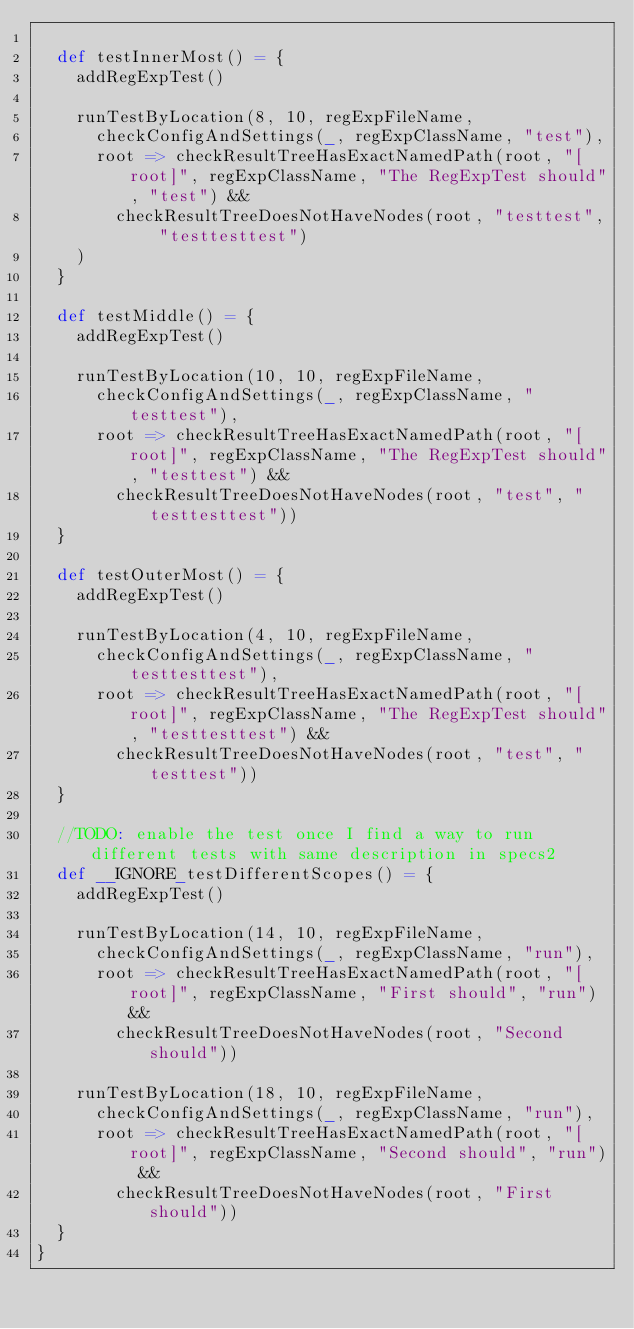Convert code to text. <code><loc_0><loc_0><loc_500><loc_500><_Scala_>
  def testInnerMost() = {
    addRegExpTest()

    runTestByLocation(8, 10, regExpFileName,
      checkConfigAndSettings(_, regExpClassName, "test"),
      root => checkResultTreeHasExactNamedPath(root, "[root]", regExpClassName, "The RegExpTest should", "test") &&
        checkResultTreeDoesNotHaveNodes(root, "testtest", "testtesttest")
    )
  }

  def testMiddle() = {
    addRegExpTest()

    runTestByLocation(10, 10, regExpFileName,
      checkConfigAndSettings(_, regExpClassName, "testtest"),
      root => checkResultTreeHasExactNamedPath(root, "[root]", regExpClassName, "The RegExpTest should", "testtest") &&
        checkResultTreeDoesNotHaveNodes(root, "test", "testtesttest"))
  }

  def testOuterMost() = {
    addRegExpTest()

    runTestByLocation(4, 10, regExpFileName,
      checkConfigAndSettings(_, regExpClassName, "testtesttest"),
      root => checkResultTreeHasExactNamedPath(root, "[root]", regExpClassName, "The RegExpTest should", "testtesttest") &&
        checkResultTreeDoesNotHaveNodes(root, "test", "testtest"))
  }

  //TODO: enable the test once I find a way to run different tests with same description in specs2
  def __IGNORE_testDifferentScopes() = {
    addRegExpTest()

    runTestByLocation(14, 10, regExpFileName,
      checkConfigAndSettings(_, regExpClassName, "run"),
      root => checkResultTreeHasExactNamedPath(root, "[root]", regExpClassName, "First should", "run") &&
        checkResultTreeDoesNotHaveNodes(root, "Second should"))

    runTestByLocation(18, 10, regExpFileName,
      checkConfigAndSettings(_, regExpClassName, "run"),
      root => checkResultTreeHasExactNamedPath(root, "[root]", regExpClassName, "Second should", "run") &&
        checkResultTreeDoesNotHaveNodes(root, "First should"))
  }
}
</code> 